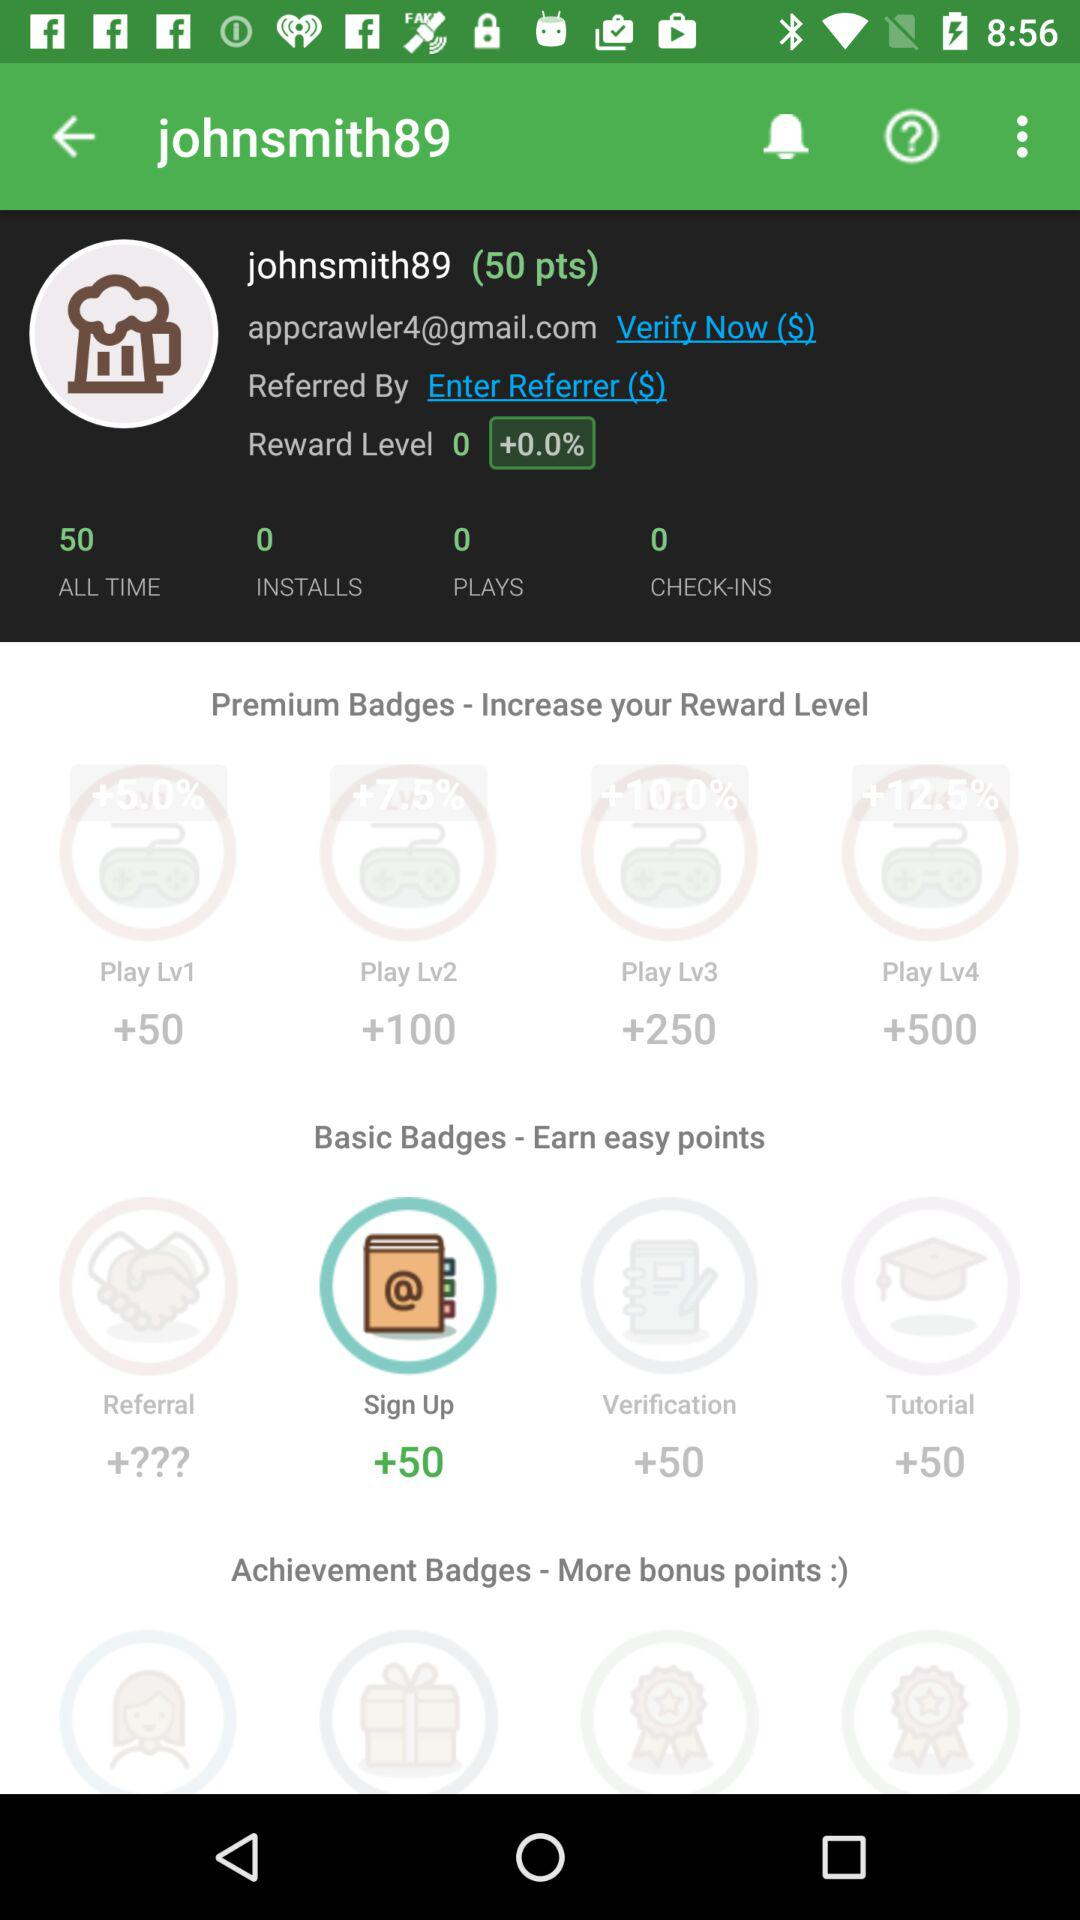How many "pts" are there for a user? The user has 50 "pts". 